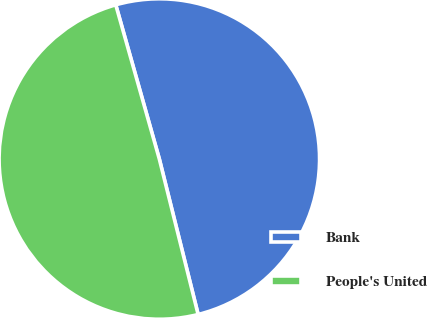Convert chart. <chart><loc_0><loc_0><loc_500><loc_500><pie_chart><fcel>Bank<fcel>People's United<nl><fcel>50.49%<fcel>49.51%<nl></chart> 